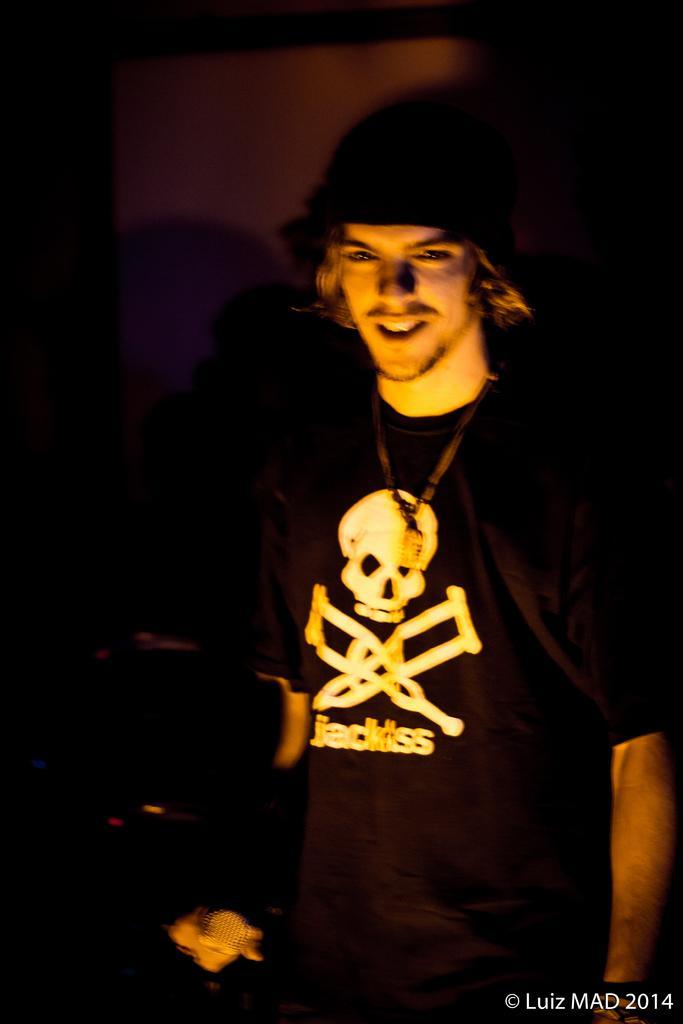Please provide a concise description of this image. In the image there is a man in black t-shirt and cap smiling and the background is blurry. 